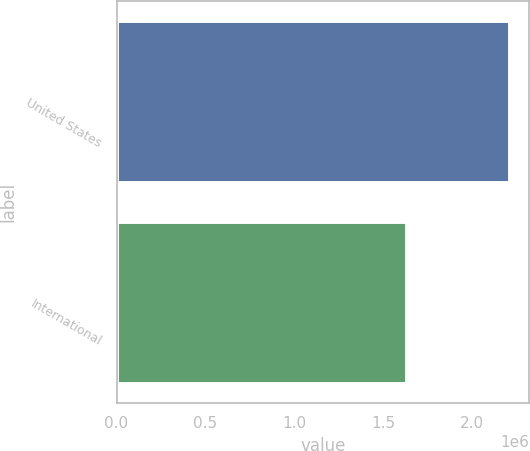Convert chart to OTSL. <chart><loc_0><loc_0><loc_500><loc_500><bar_chart><fcel>United States<fcel>International<nl><fcel>2.21084e+06<fcel>1.62672e+06<nl></chart> 